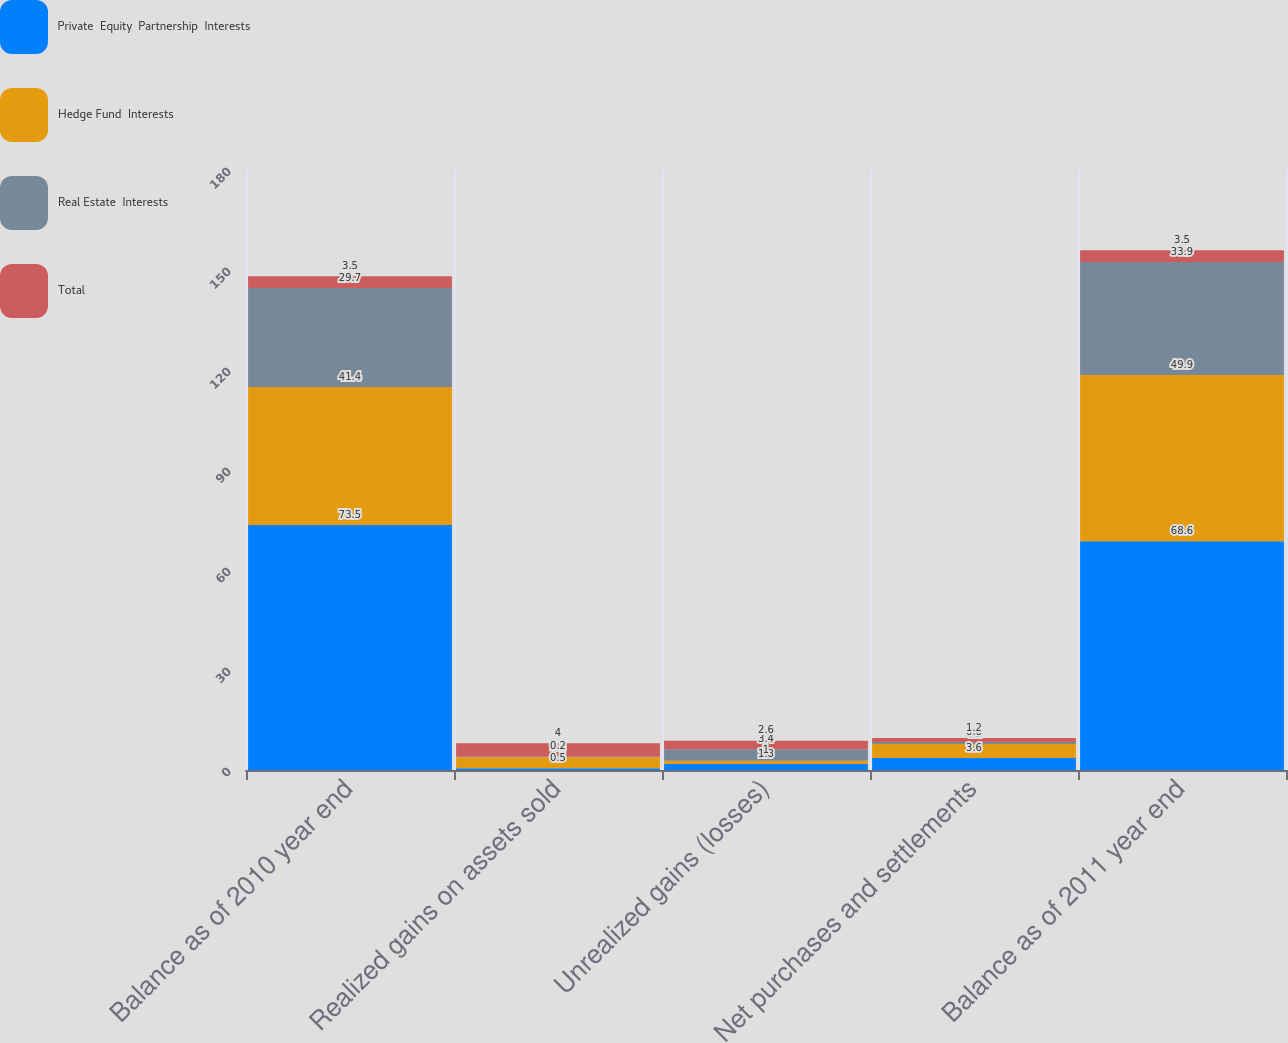Convert chart. <chart><loc_0><loc_0><loc_500><loc_500><stacked_bar_chart><ecel><fcel>Balance as of 2010 year end<fcel>Realized gains on assets sold<fcel>Unrealized gains (losses)<fcel>Net purchases and settlements<fcel>Balance as of 2011 year end<nl><fcel>Private  Equity  Partnership  Interests<fcel>73.5<fcel>0.5<fcel>1.8<fcel>3.6<fcel>68.6<nl><fcel>Hedge Fund  Interests<fcel>41.4<fcel>3.3<fcel>1<fcel>4.2<fcel>49.9<nl><fcel>Real Estate  Interests<fcel>29.7<fcel>0.2<fcel>3.4<fcel>0.6<fcel>33.9<nl><fcel>Total<fcel>3.5<fcel>4<fcel>2.6<fcel>1.2<fcel>3.5<nl></chart> 